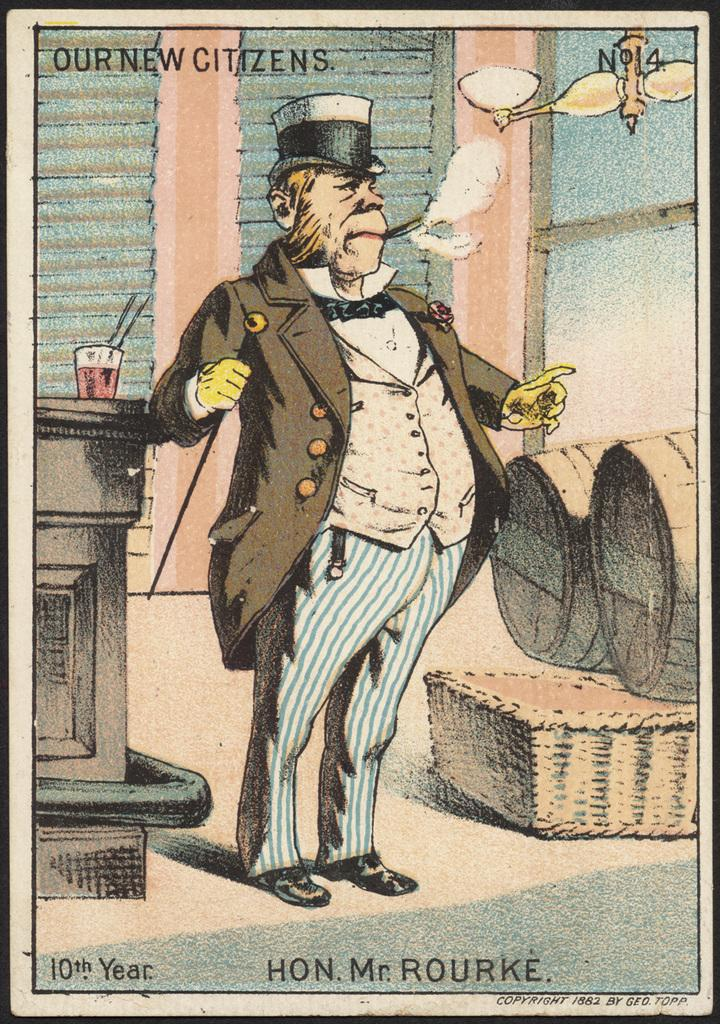What type of image is depicted in the poster? The image is a comic poster. Can you describe the main character in the poster? There is a man in the poster, and he is wearing a brown coat. What is the man holding in his hand? The man is holding a stick in his hand. What activity is the man engaged in? The man is smoking. What type of rhythm can be heard in the background of the comic poster? There is no audible rhythm present in the comic poster, as it is a static image. 